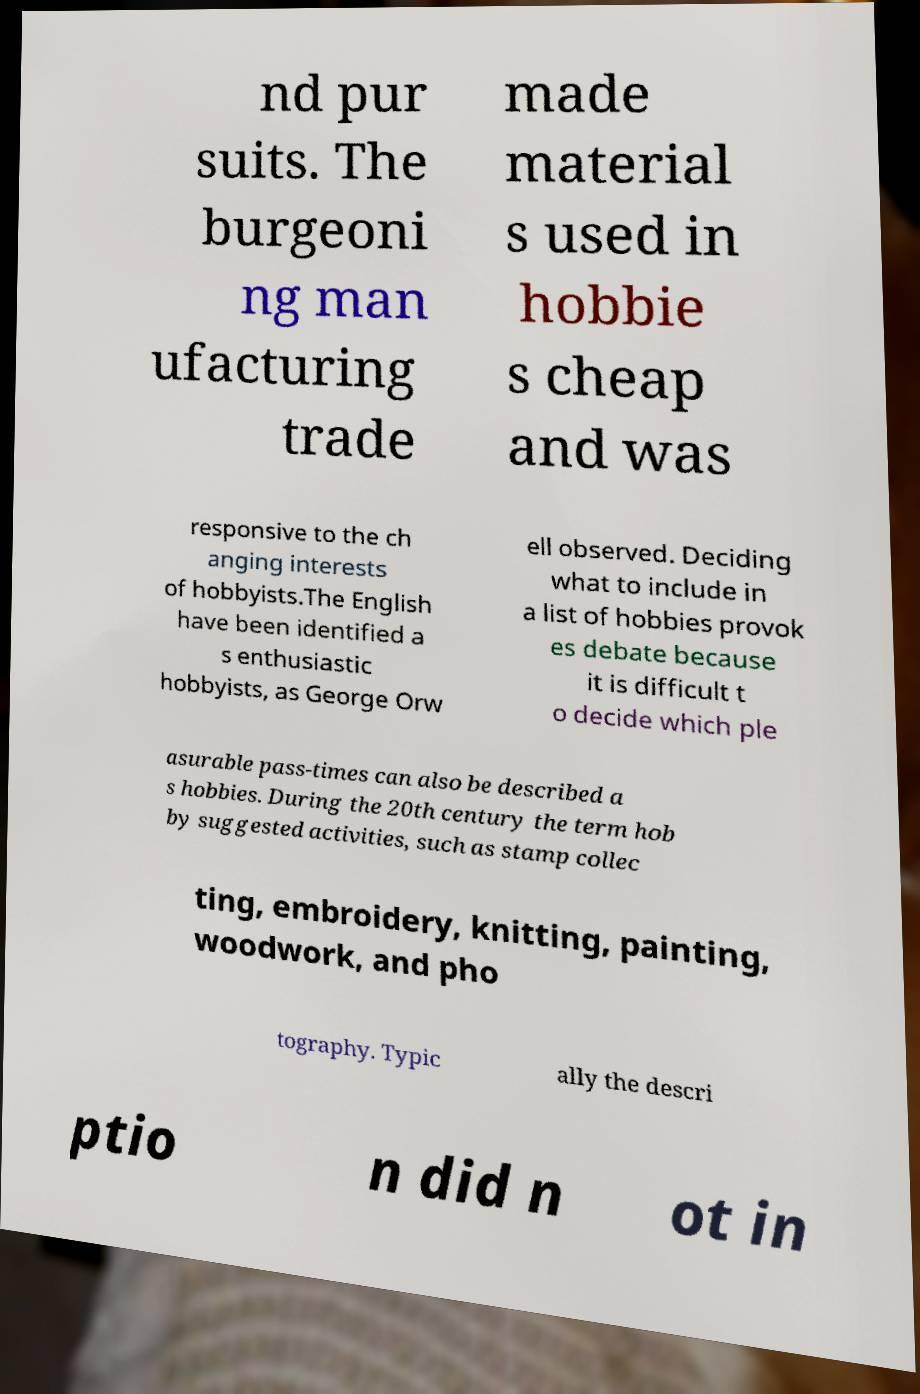Please identify and transcribe the text found in this image. nd pur suits. The burgeoni ng man ufacturing trade made material s used in hobbie s cheap and was responsive to the ch anging interests of hobbyists.The English have been identified a s enthusiastic hobbyists, as George Orw ell observed. Deciding what to include in a list of hobbies provok es debate because it is difficult t o decide which ple asurable pass-times can also be described a s hobbies. During the 20th century the term hob by suggested activities, such as stamp collec ting, embroidery, knitting, painting, woodwork, and pho tography. Typic ally the descri ptio n did n ot in 